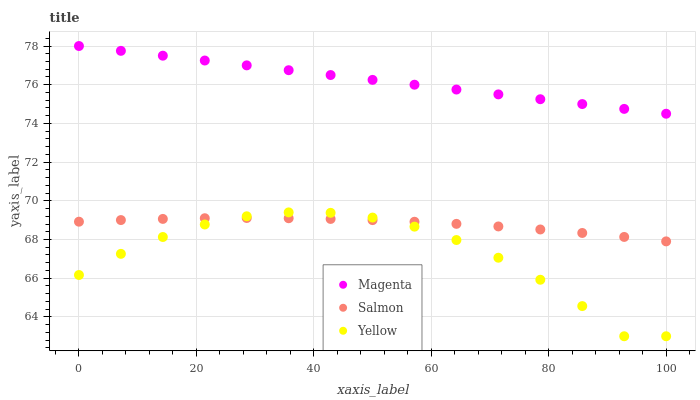Does Yellow have the minimum area under the curve?
Answer yes or no. Yes. Does Magenta have the maximum area under the curve?
Answer yes or no. Yes. Does Salmon have the minimum area under the curve?
Answer yes or no. No. Does Salmon have the maximum area under the curve?
Answer yes or no. No. Is Magenta the smoothest?
Answer yes or no. Yes. Is Yellow the roughest?
Answer yes or no. Yes. Is Salmon the smoothest?
Answer yes or no. No. Is Salmon the roughest?
Answer yes or no. No. Does Yellow have the lowest value?
Answer yes or no. Yes. Does Salmon have the lowest value?
Answer yes or no. No. Does Magenta have the highest value?
Answer yes or no. Yes. Does Yellow have the highest value?
Answer yes or no. No. Is Yellow less than Magenta?
Answer yes or no. Yes. Is Magenta greater than Salmon?
Answer yes or no. Yes. Does Yellow intersect Salmon?
Answer yes or no. Yes. Is Yellow less than Salmon?
Answer yes or no. No. Is Yellow greater than Salmon?
Answer yes or no. No. Does Yellow intersect Magenta?
Answer yes or no. No. 